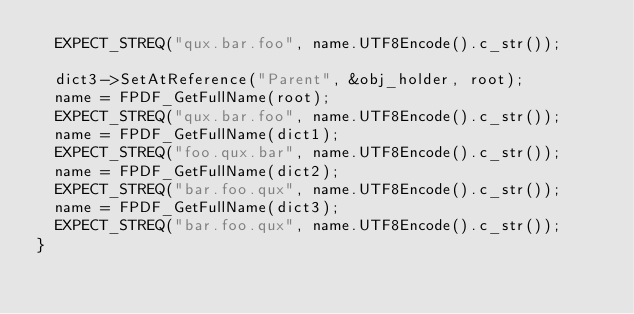<code> <loc_0><loc_0><loc_500><loc_500><_C++_>  EXPECT_STREQ("qux.bar.foo", name.UTF8Encode().c_str());

  dict3->SetAtReference("Parent", &obj_holder, root);
  name = FPDF_GetFullName(root);
  EXPECT_STREQ("qux.bar.foo", name.UTF8Encode().c_str());
  name = FPDF_GetFullName(dict1);
  EXPECT_STREQ("foo.qux.bar", name.UTF8Encode().c_str());
  name = FPDF_GetFullName(dict2);
  EXPECT_STREQ("bar.foo.qux", name.UTF8Encode().c_str());
  name = FPDF_GetFullName(dict3);
  EXPECT_STREQ("bar.foo.qux", name.UTF8Encode().c_str());
}
</code> 